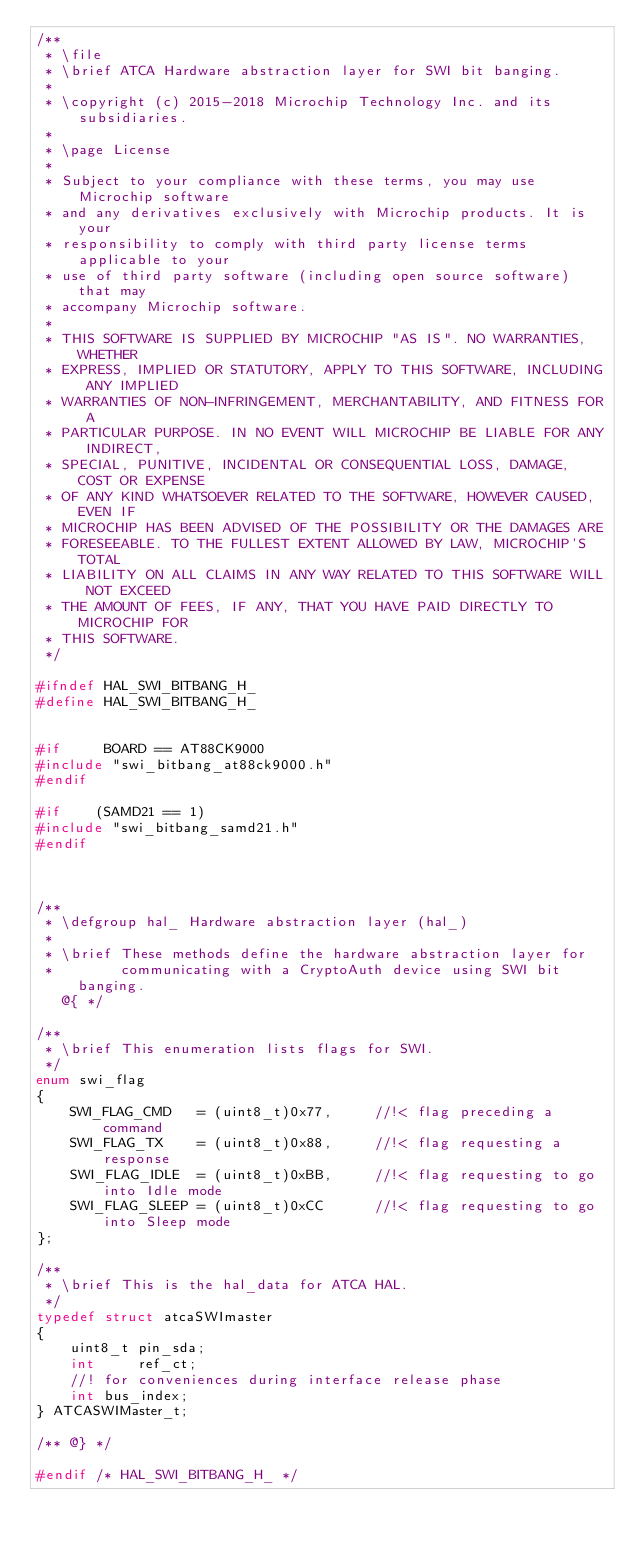<code> <loc_0><loc_0><loc_500><loc_500><_C_>/**
 * \file
 * \brief ATCA Hardware abstraction layer for SWI bit banging.
 *
 * \copyright (c) 2015-2018 Microchip Technology Inc. and its subsidiaries.
 *
 * \page License
 * 
 * Subject to your compliance with these terms, you may use Microchip software
 * and any derivatives exclusively with Microchip products. It is your
 * responsibility to comply with third party license terms applicable to your
 * use of third party software (including open source software) that may
 * accompany Microchip software.
 * 
 * THIS SOFTWARE IS SUPPLIED BY MICROCHIP "AS IS". NO WARRANTIES, WHETHER
 * EXPRESS, IMPLIED OR STATUTORY, APPLY TO THIS SOFTWARE, INCLUDING ANY IMPLIED
 * WARRANTIES OF NON-INFRINGEMENT, MERCHANTABILITY, AND FITNESS FOR A
 * PARTICULAR PURPOSE. IN NO EVENT WILL MICROCHIP BE LIABLE FOR ANY INDIRECT,
 * SPECIAL, PUNITIVE, INCIDENTAL OR CONSEQUENTIAL LOSS, DAMAGE, COST OR EXPENSE
 * OF ANY KIND WHATSOEVER RELATED TO THE SOFTWARE, HOWEVER CAUSED, EVEN IF
 * MICROCHIP HAS BEEN ADVISED OF THE POSSIBILITY OR THE DAMAGES ARE
 * FORESEEABLE. TO THE FULLEST EXTENT ALLOWED BY LAW, MICROCHIP'S TOTAL
 * LIABILITY ON ALL CLAIMS IN ANY WAY RELATED TO THIS SOFTWARE WILL NOT EXCEED
 * THE AMOUNT OF FEES, IF ANY, THAT YOU HAVE PAID DIRECTLY TO MICROCHIP FOR
 * THIS SOFTWARE.
 */

#ifndef HAL_SWI_BITBANG_H_
#define HAL_SWI_BITBANG_H_


#if     BOARD == AT88CK9000
#include "swi_bitbang_at88ck9000.h"
#endif

#if    (SAMD21 == 1)
#include "swi_bitbang_samd21.h"
#endif



/**
 * \defgroup hal_ Hardware abstraction layer (hal_)
 *
 * \brief These methods define the hardware abstraction layer for
 *        communicating with a CryptoAuth device using SWI bit banging.
   @{ */

/**
 * \brief This enumeration lists flags for SWI.
 */
enum swi_flag
{
    SWI_FLAG_CMD   = (uint8_t)0x77,     //!< flag preceding a command
    SWI_FLAG_TX    = (uint8_t)0x88,     //!< flag requesting a response
    SWI_FLAG_IDLE  = (uint8_t)0xBB,     //!< flag requesting to go into Idle mode
    SWI_FLAG_SLEEP = (uint8_t)0xCC      //!< flag requesting to go into Sleep mode
};

/**
 * \brief This is the hal_data for ATCA HAL.
 */
typedef struct atcaSWImaster
{
    uint8_t pin_sda;
    int     ref_ct;
    //! for conveniences during interface release phase
    int bus_index;
} ATCASWIMaster_t;

/** @} */

#endif /* HAL_SWI_BITBANG_H_ */</code> 